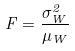Convert formula to latex. <formula><loc_0><loc_0><loc_500><loc_500>F = \frac { \sigma _ { W } ^ { 2 } } { \mu _ { W } }</formula> 